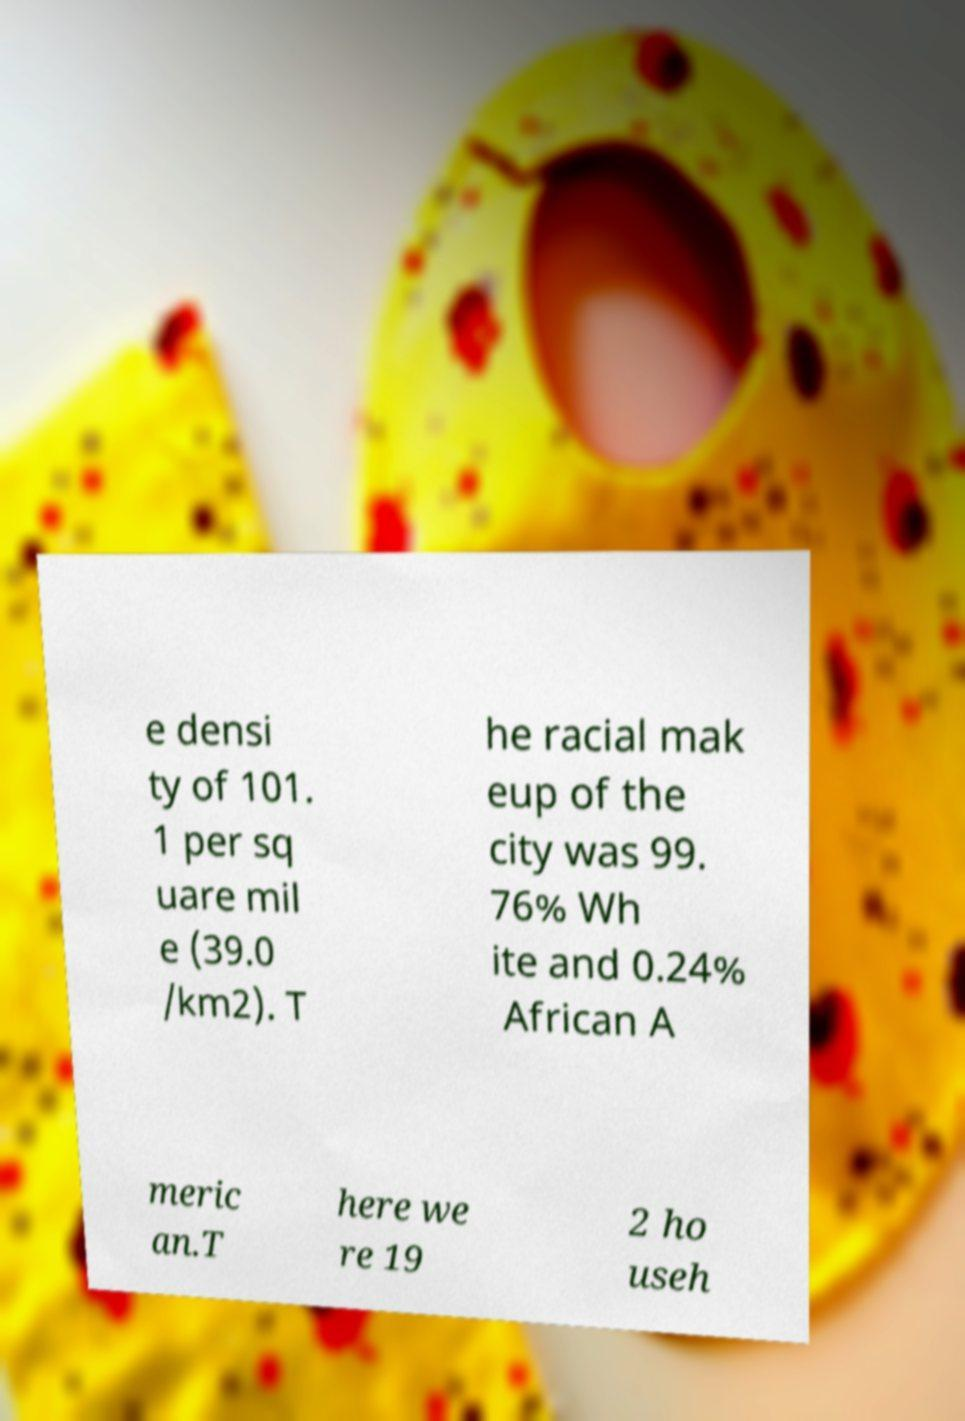Could you extract and type out the text from this image? e densi ty of 101. 1 per sq uare mil e (39.0 /km2). T he racial mak eup of the city was 99. 76% Wh ite and 0.24% African A meric an.T here we re 19 2 ho useh 